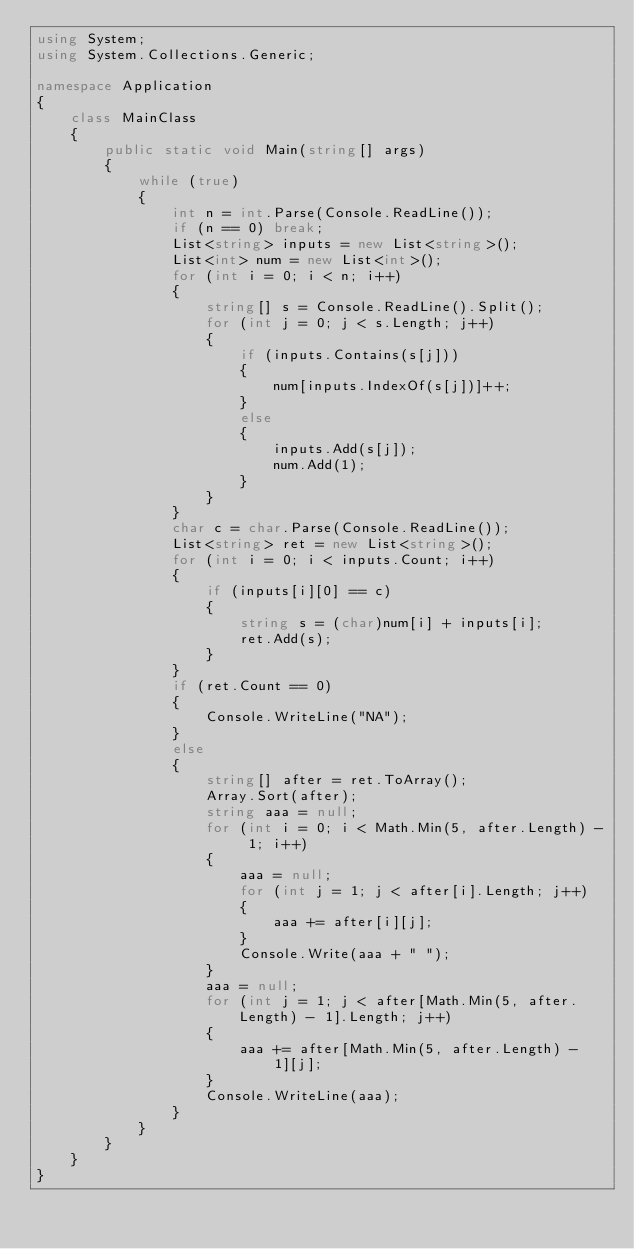<code> <loc_0><loc_0><loc_500><loc_500><_C#_>using System;
using System.Collections.Generic;

namespace Application
{
    class MainClass
    {
        public static void Main(string[] args)
        {
            while (true)
            {
                int n = int.Parse(Console.ReadLine());
                if (n == 0) break;
                List<string> inputs = new List<string>();
                List<int> num = new List<int>();
                for (int i = 0; i < n; i++)
                {
                    string[] s = Console.ReadLine().Split();
                    for (int j = 0; j < s.Length; j++)
                    {
                        if (inputs.Contains(s[j]))
                        {
                            num[inputs.IndexOf(s[j])]++;
                        }
                        else
                        {
                            inputs.Add(s[j]);
                            num.Add(1);
                        }
                    }
                }
                char c = char.Parse(Console.ReadLine());
                List<string> ret = new List<string>();
                for (int i = 0; i < inputs.Count; i++)
                {
                    if (inputs[i][0] == c)
                    {
                        string s = (char)num[i] + inputs[i];
                        ret.Add(s);
                    }
                }
                if (ret.Count == 0)
                {
                    Console.WriteLine("NA");
                }
                else
                {
                    string[] after = ret.ToArray();
                    Array.Sort(after);
                    string aaa = null;
                    for (int i = 0; i < Math.Min(5, after.Length) - 1; i++)
                    {
                        aaa = null;
                        for (int j = 1; j < after[i].Length; j++)
                        {
                            aaa += after[i][j];
                        }
                        Console.Write(aaa + " ");
                    }
                    aaa = null;
                    for (int j = 1; j < after[Math.Min(5, after.Length) - 1].Length; j++)
                    {
                        aaa += after[Math.Min(5, after.Length) - 1][j];
                    }
                    Console.WriteLine(aaa);
                }
            }
        }
    }
}</code> 